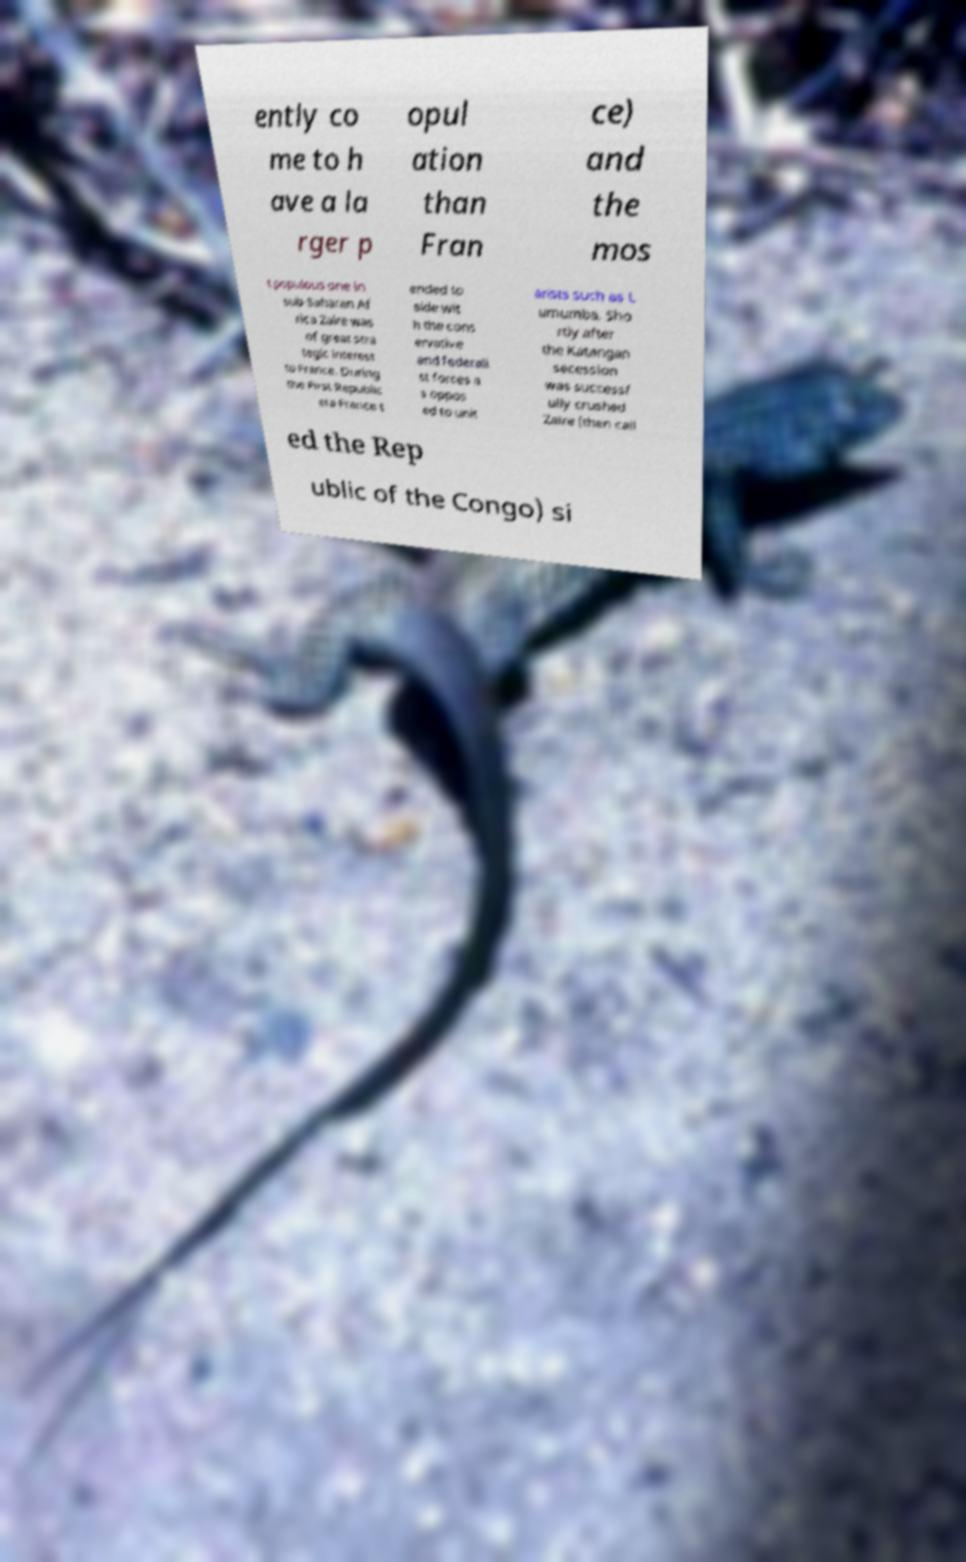Can you accurately transcribe the text from the provided image for me? ently co me to h ave a la rger p opul ation than Fran ce) and the mos t populous one in sub-Saharan Af rica Zaire was of great stra tegic interest to France. During the First Republic era France t ended to side wit h the cons ervative and federali st forces a s oppos ed to unit arists such as L umumba. Sho rtly after the Katangan secession was successf ully crushed Zaire (then call ed the Rep ublic of the Congo) si 